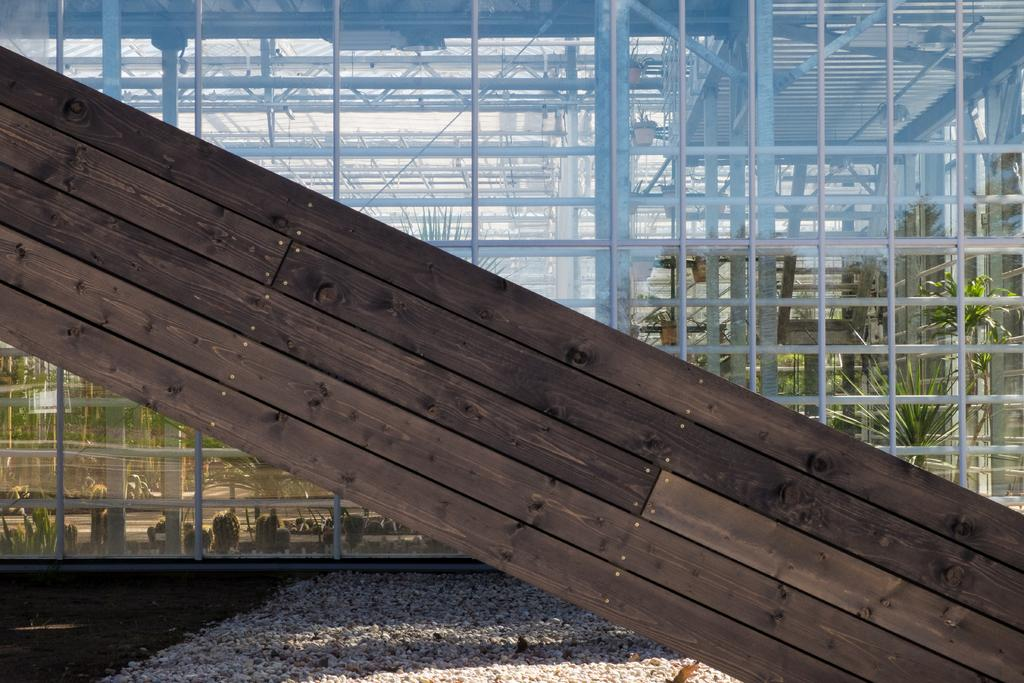What is the main object in the center of the image? There is a wooden pillar in the image, and it is at the center. What can be seen in the background of the image? There is a glass building in the background of the image. What type of vegetation is on the right side of the image? There are plants on the right side of the image. How many ants are crawling on the wooden pillar in the image? There are no ants present on the wooden pillar in the image. What type of chain is wrapped around the plants on the right side of the image? There is no chain present around the plants on the right side of the image. 